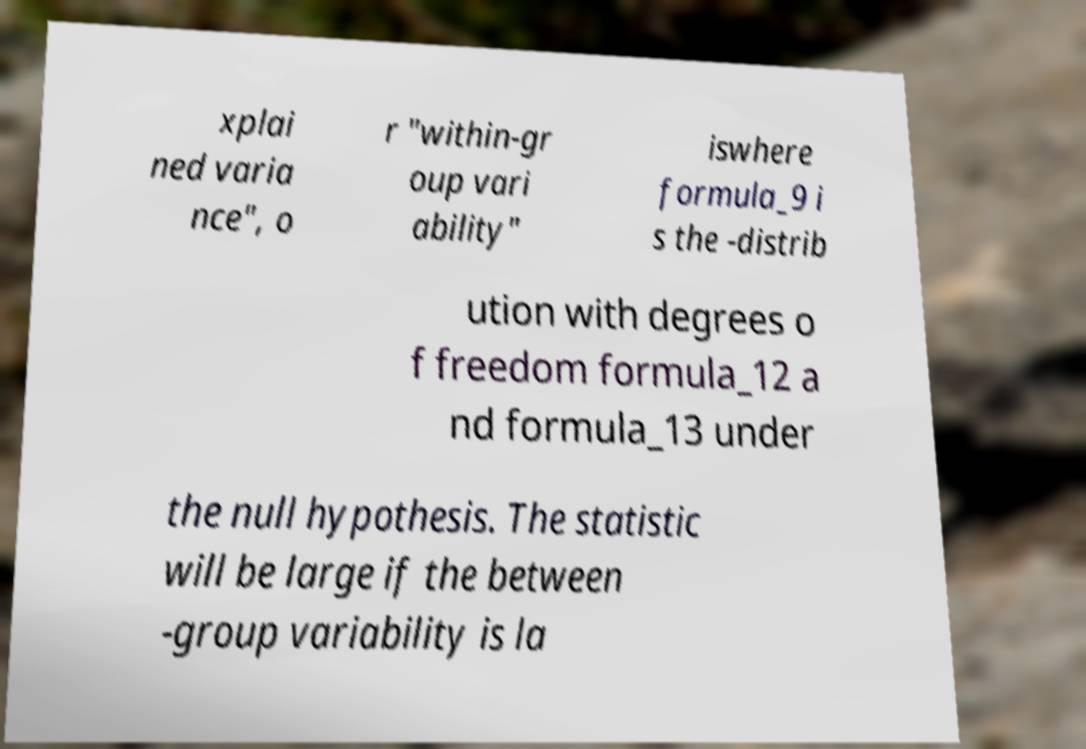Please identify and transcribe the text found in this image. xplai ned varia nce", o r "within-gr oup vari ability" iswhere formula_9 i s the -distrib ution with degrees o f freedom formula_12 a nd formula_13 under the null hypothesis. The statistic will be large if the between -group variability is la 